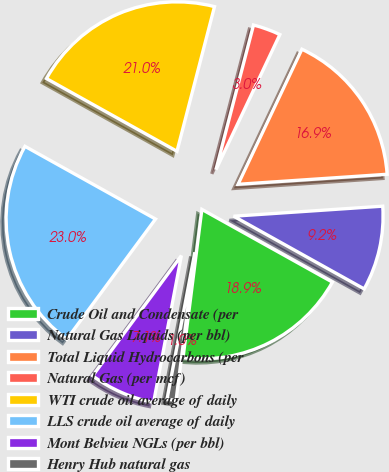Convert chart to OTSL. <chart><loc_0><loc_0><loc_500><loc_500><pie_chart><fcel>Crude Oil and Condensate (per<fcel>Natural Gas Liquids (per bbl)<fcel>Total Liquid Hydrocarbons (per<fcel>Natural Gas (per mcf)<fcel>WTI crude oil average of daily<fcel>LLS crude oil average of daily<fcel>Mont Belvieu NGLs (per bbl)<fcel>Henry Hub natural gas<nl><fcel>18.92%<fcel>9.16%<fcel>16.9%<fcel>2.99%<fcel>20.95%<fcel>22.97%<fcel>7.14%<fcel>0.97%<nl></chart> 